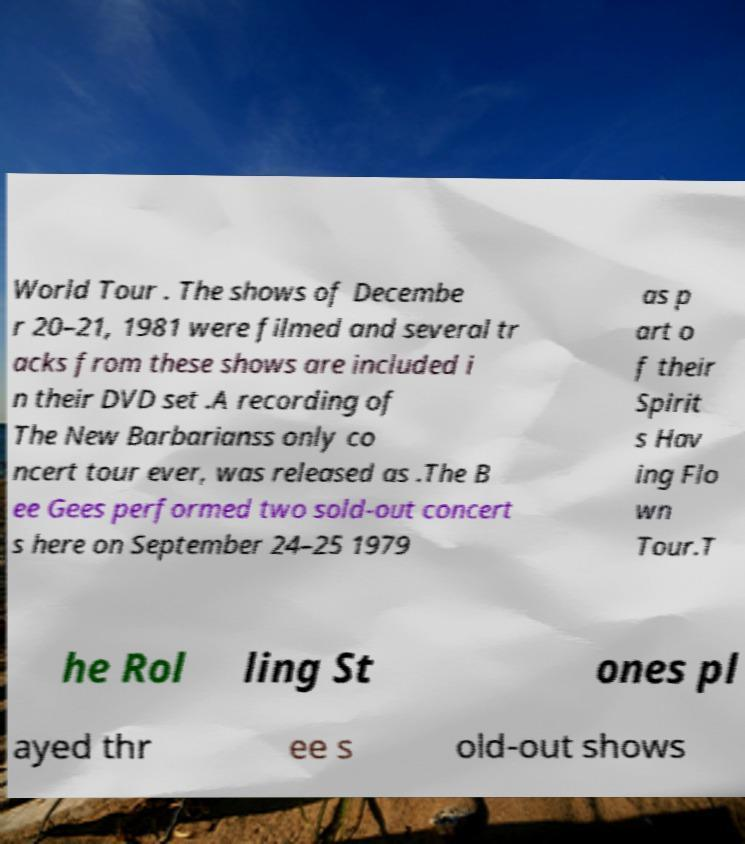There's text embedded in this image that I need extracted. Can you transcribe it verbatim? World Tour . The shows of Decembe r 20–21, 1981 were filmed and several tr acks from these shows are included i n their DVD set .A recording of The New Barbarianss only co ncert tour ever, was released as .The B ee Gees performed two sold-out concert s here on September 24–25 1979 as p art o f their Spirit s Hav ing Flo wn Tour.T he Rol ling St ones pl ayed thr ee s old-out shows 